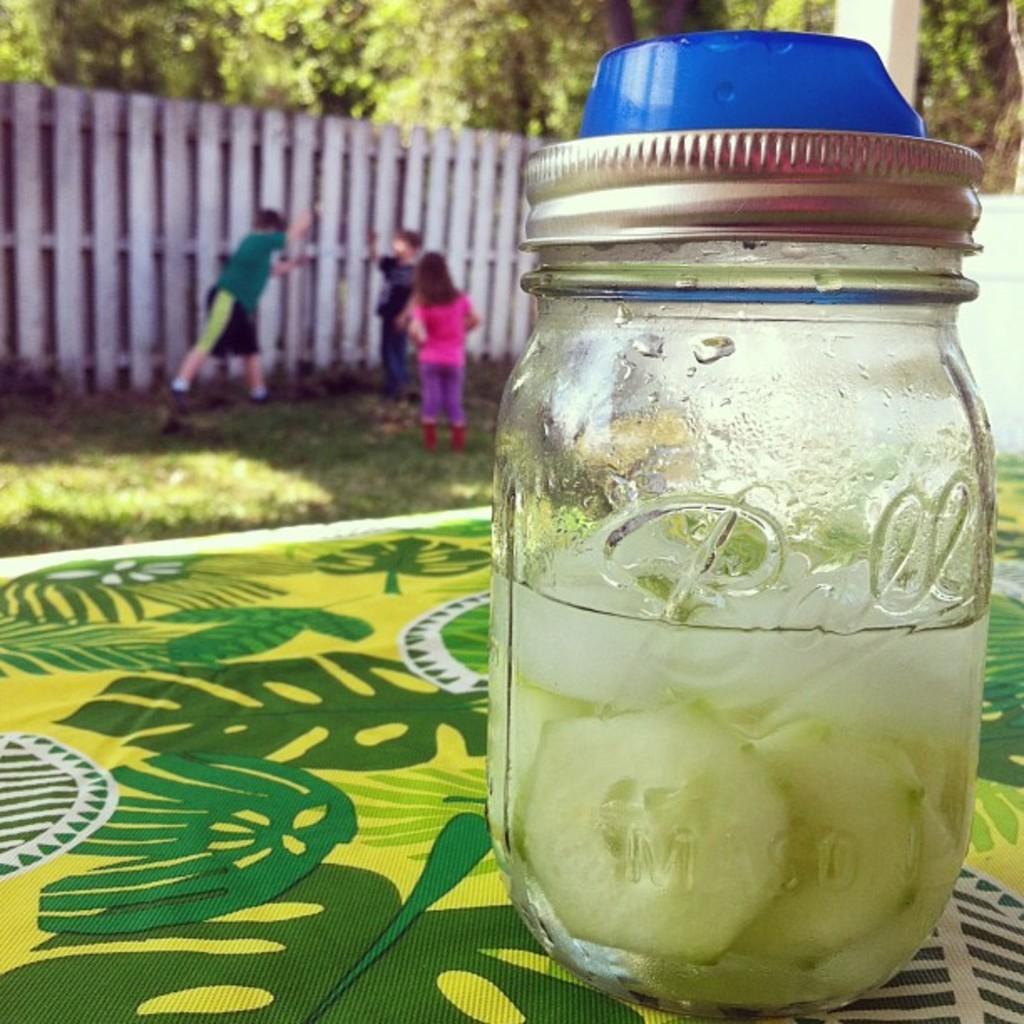In one or two sentences, can you explain what this image depicts? In the center of the image we can see cucumbers and water in jar placed on the table. In the background we can see fencing, persons, grass and trees. 